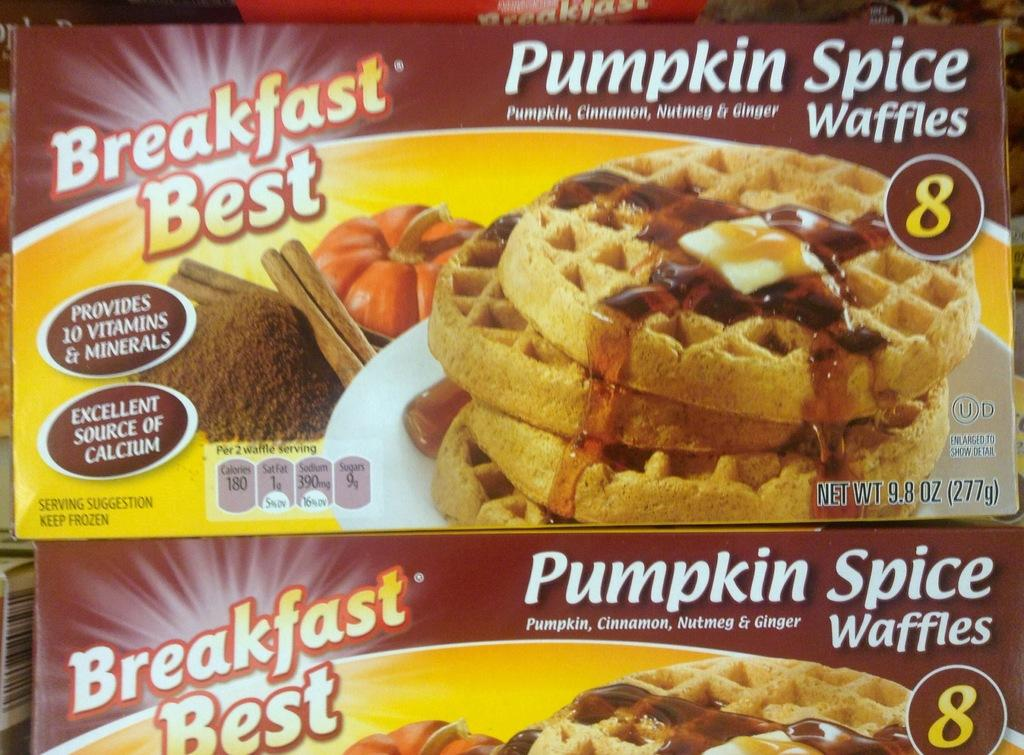How many boxes are visible in the image? There are two boxes in the image. What is depicted on the boxes? There are pictures of food on the boxes. What else can be found on the boxes besides the images? There is text present on the boxes. What type of crow is sitting on top of the boxes in the image? There is no crow present in the image; it only features two boxes with pictures of food and text. 